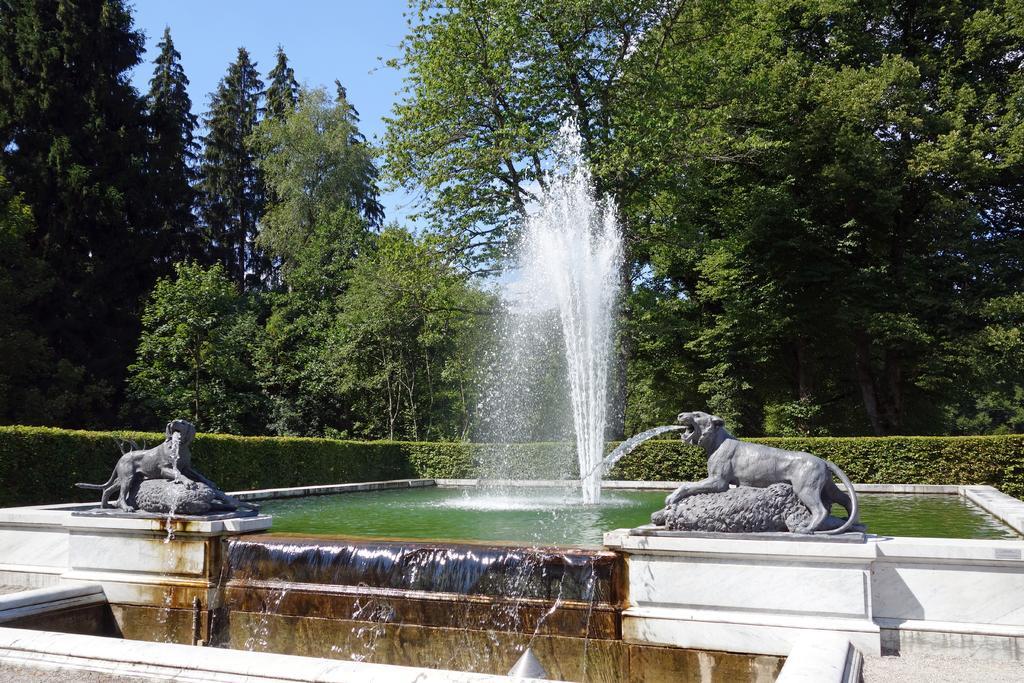In one or two sentences, can you explain what this image depicts? In this picture we can see statues of animals, wall and water fountain. In the background of the image we can see plants, trees and sky. 